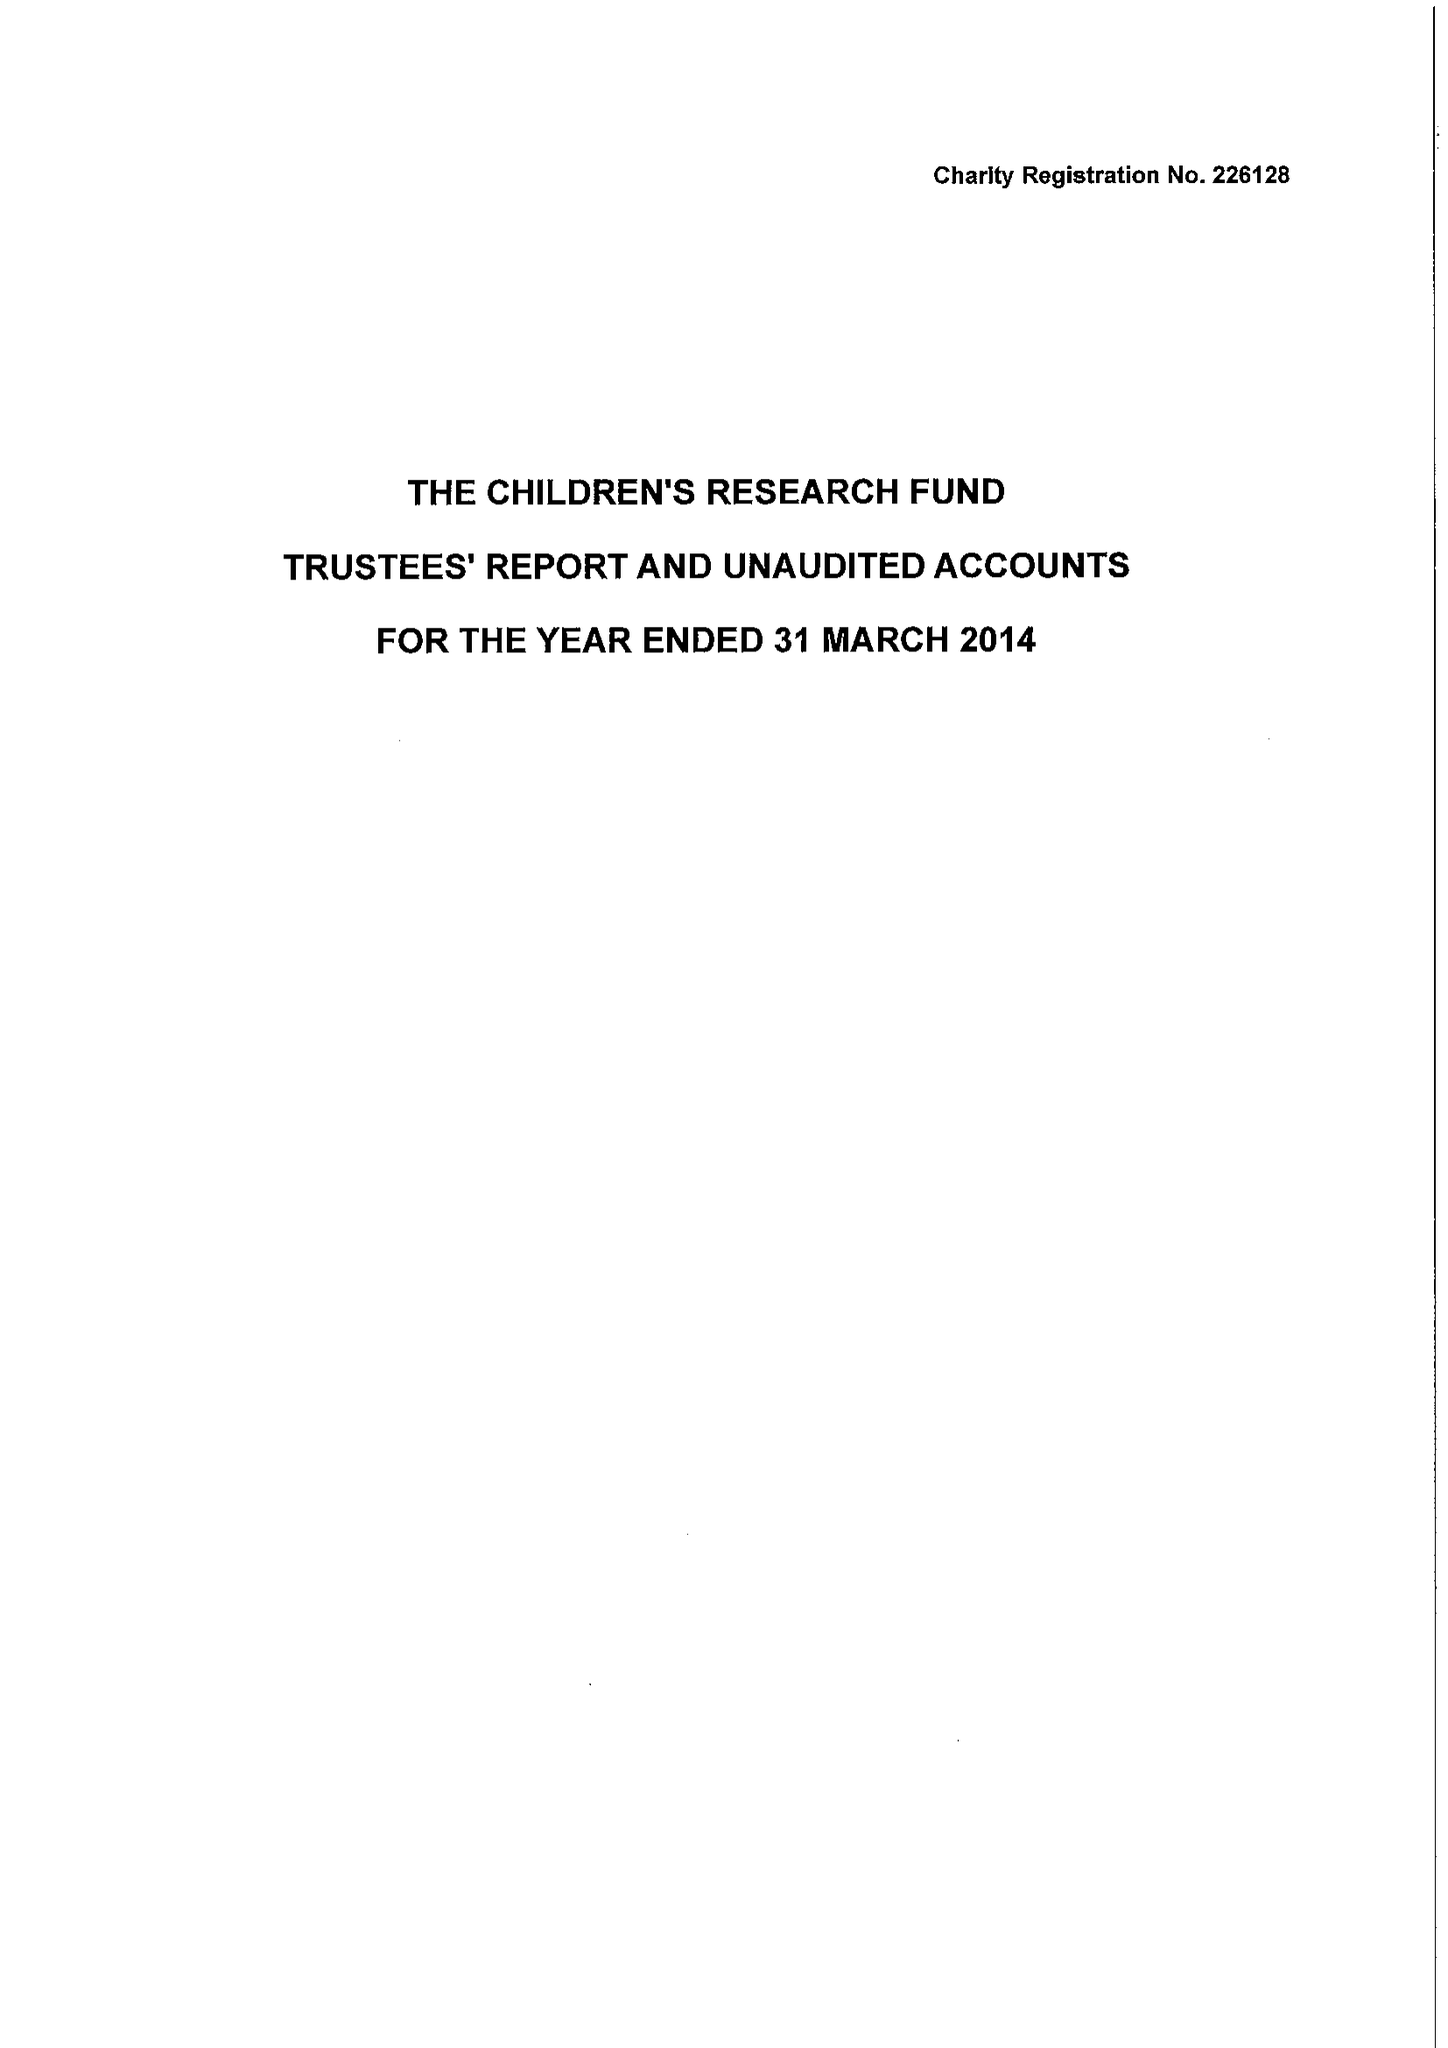What is the value for the address__street_line?
Answer the question using a single word or phrase. 14 TAN-Y-BRYN 